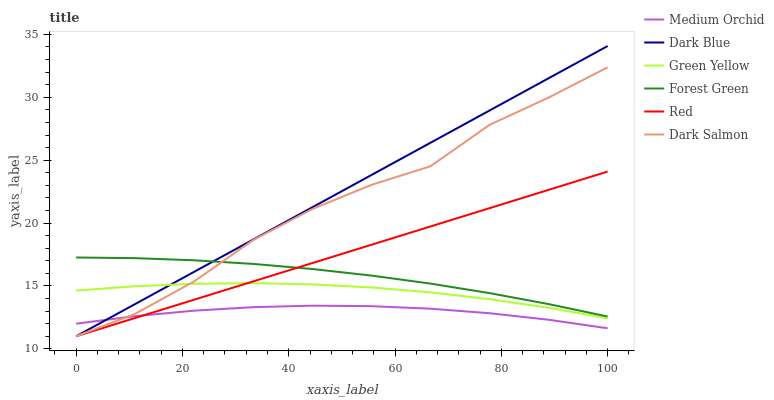Does Medium Orchid have the minimum area under the curve?
Answer yes or no. Yes. Does Dark Blue have the maximum area under the curve?
Answer yes or no. Yes. Does Dark Salmon have the minimum area under the curve?
Answer yes or no. No. Does Dark Salmon have the maximum area under the curve?
Answer yes or no. No. Is Dark Blue the smoothest?
Answer yes or no. Yes. Is Dark Salmon the roughest?
Answer yes or no. Yes. Is Dark Salmon the smoothest?
Answer yes or no. No. Is Dark Blue the roughest?
Answer yes or no. No. Does Dark Salmon have the lowest value?
Answer yes or no. Yes. Does Forest Green have the lowest value?
Answer yes or no. No. Does Dark Blue have the highest value?
Answer yes or no. Yes. Does Dark Salmon have the highest value?
Answer yes or no. No. Is Green Yellow less than Forest Green?
Answer yes or no. Yes. Is Forest Green greater than Medium Orchid?
Answer yes or no. Yes. Does Red intersect Forest Green?
Answer yes or no. Yes. Is Red less than Forest Green?
Answer yes or no. No. Is Red greater than Forest Green?
Answer yes or no. No. Does Green Yellow intersect Forest Green?
Answer yes or no. No. 